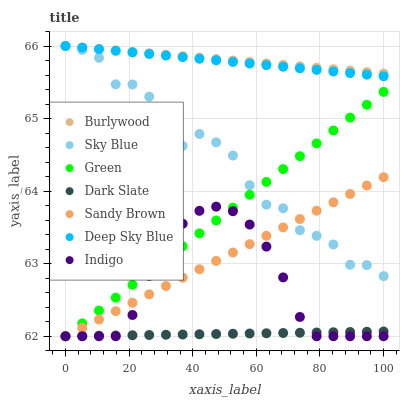Does Dark Slate have the minimum area under the curve?
Answer yes or no. Yes. Does Burlywood have the maximum area under the curve?
Answer yes or no. Yes. Does Burlywood have the minimum area under the curve?
Answer yes or no. No. Does Dark Slate have the maximum area under the curve?
Answer yes or no. No. Is Green the smoothest?
Answer yes or no. Yes. Is Sky Blue the roughest?
Answer yes or no. Yes. Is Burlywood the smoothest?
Answer yes or no. No. Is Burlywood the roughest?
Answer yes or no. No. Does Indigo have the lowest value?
Answer yes or no. Yes. Does Burlywood have the lowest value?
Answer yes or no. No. Does Sky Blue have the highest value?
Answer yes or no. Yes. Does Dark Slate have the highest value?
Answer yes or no. No. Is Dark Slate less than Deep Sky Blue?
Answer yes or no. Yes. Is Deep Sky Blue greater than Green?
Answer yes or no. Yes. Does Sandy Brown intersect Green?
Answer yes or no. Yes. Is Sandy Brown less than Green?
Answer yes or no. No. Is Sandy Brown greater than Green?
Answer yes or no. No. Does Dark Slate intersect Deep Sky Blue?
Answer yes or no. No. 